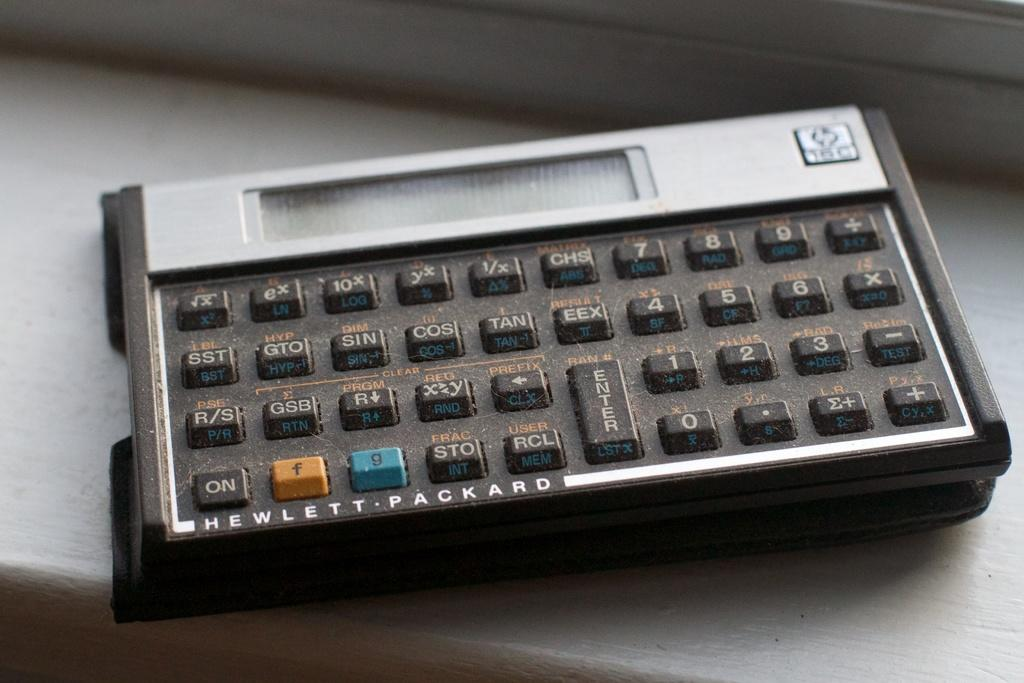<image>
Provide a brief description of the given image. A black and silver Hewlett Packard calculator with one orange and one blue button. 